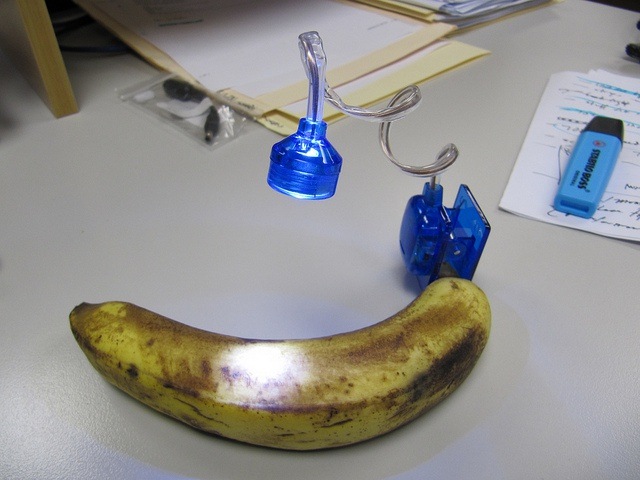Describe the objects in this image and their specific colors. I can see a banana in black, olive, and white tones in this image. 